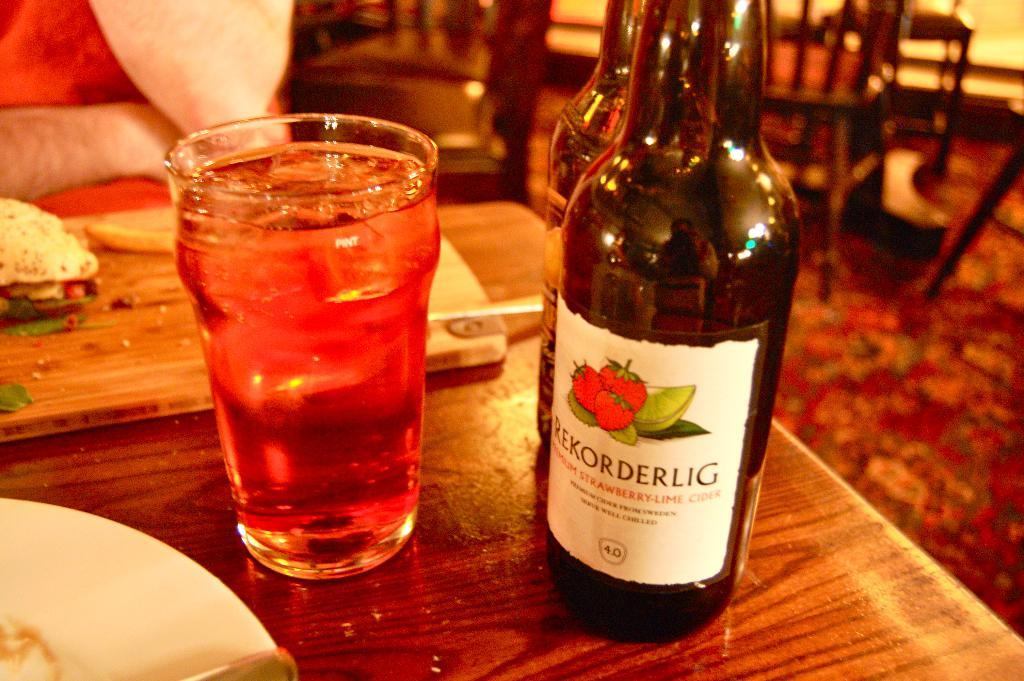Provide a one-sentence caption for the provided image. A bottle of Rekorderlig sits on a table next to a filled glass. 